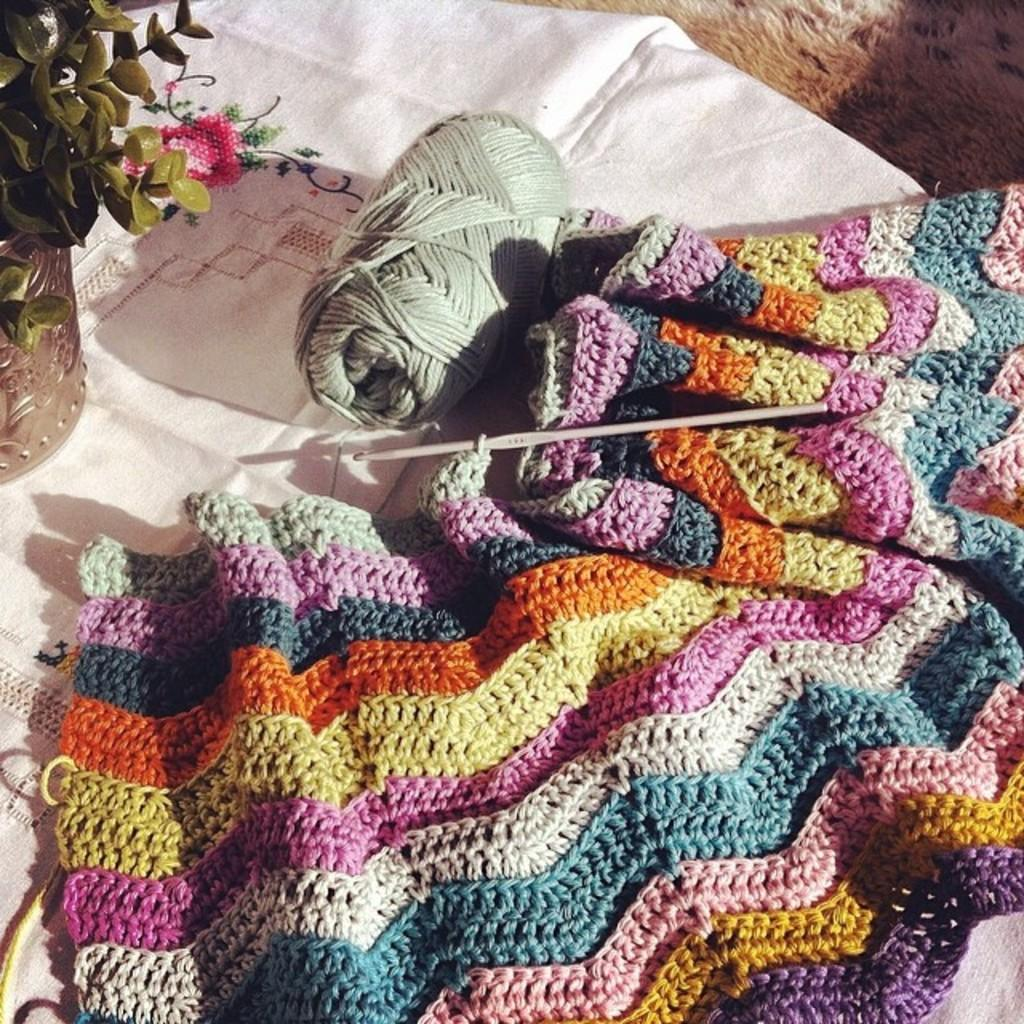What type of material is visible in the image? There is a wool cloth in the image. What objects are associated with sewing in the image? There is a needle and thread in the image. What type of plant can be seen in the image? There is a houseplant in the image. Where might the wool cloth be located in the image? The cloth may be on the floor in the image. What type of setting is suggested by the image? The image is likely taken in a room. What type of industry is depicted in the image? There is no industry depicted in the image; it features a wool cloth, needle, thread, houseplant, and possibly a floor setting. Is there a river flowing through the room in the image? There is no river present in the image; it is focused on the wool cloth, needle, thread, houseplant, and possibly a floor setting. 